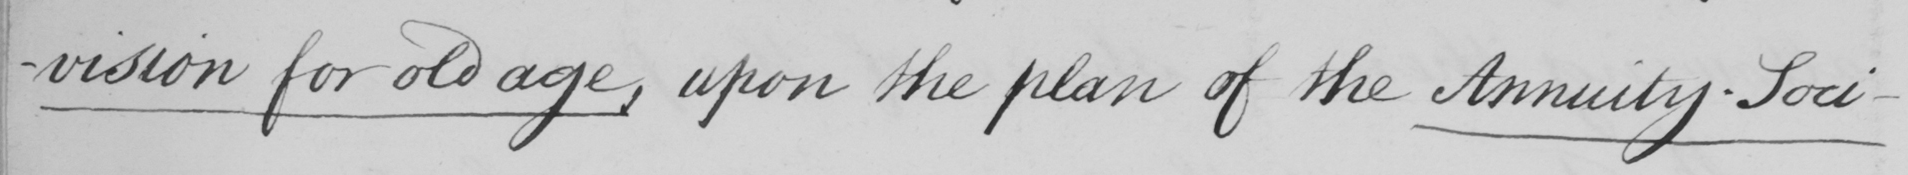What does this handwritten line say? -vision for old age , upon the plan of the Annuity Soci- 